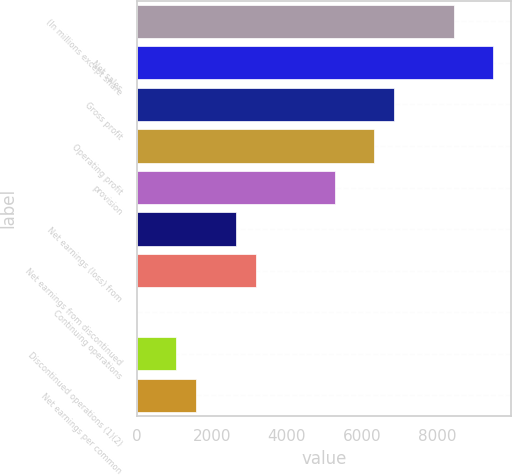Convert chart to OTSL. <chart><loc_0><loc_0><loc_500><loc_500><bar_chart><fcel>(In millions except share<fcel>Net sales<fcel>Gross profit<fcel>Operating profit<fcel>provision<fcel>Net earnings (loss) from<fcel>Net earnings from discontinued<fcel>Continuing operations<fcel>Discontinued operations (1)(2)<fcel>Net earnings per common<nl><fcel>8448.33<fcel>9504.33<fcel>6864.33<fcel>6336.33<fcel>5280.33<fcel>2640.33<fcel>3168.33<fcel>0.33<fcel>1056.33<fcel>1584.33<nl></chart> 